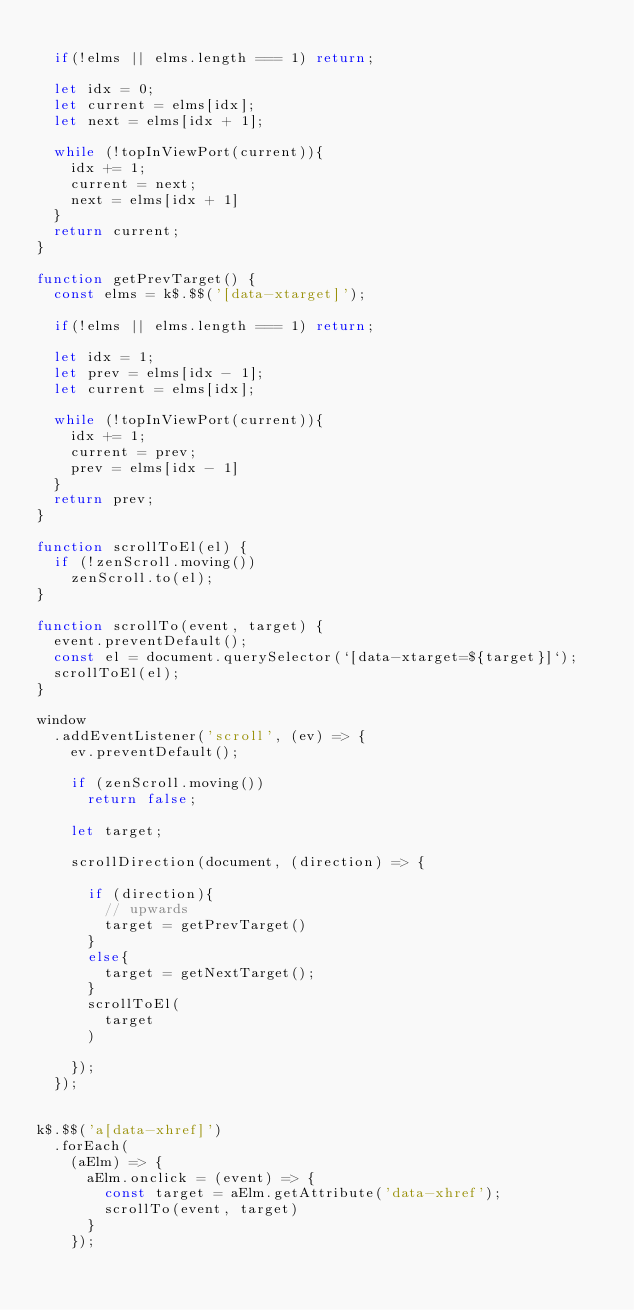Convert code to text. <code><loc_0><loc_0><loc_500><loc_500><_JavaScript_>
  if(!elms || elms.length === 1) return;

  let idx = 0;
  let current = elms[idx];
  let next = elms[idx + 1];

  while (!topInViewPort(current)){
    idx += 1;
    current = next;
    next = elms[idx + 1]
  }
  return current;
}

function getPrevTarget() {
  const elms = k$.$$('[data-xtarget]');

  if(!elms || elms.length === 1) return;

  let idx = 1;
  let prev = elms[idx - 1];
  let current = elms[idx];

  while (!topInViewPort(current)){
    idx += 1;
    current = prev;
    prev = elms[idx - 1]
  }
  return prev;
}

function scrollToEl(el) {
  if (!zenScroll.moving())
    zenScroll.to(el);
}

function scrollTo(event, target) {
  event.preventDefault();
  const el = document.querySelector(`[data-xtarget=${target}]`);
  scrollToEl(el);
}

window
  .addEventListener('scroll', (ev) => {
    ev.preventDefault();

    if (zenScroll.moving())
      return false;

    let target;

    scrollDirection(document, (direction) => {

      if (direction){
        // upwards
        target = getPrevTarget()
      }
      else{
        target = getNextTarget();
      }
      scrollToEl(
        target
      )

    });
  });


k$.$$('a[data-xhref]')
  .forEach(
    (aElm) => {
      aElm.onclick = (event) => {
        const target = aElm.getAttribute('data-xhref');
        scrollTo(event, target)
      }
    });

</code> 